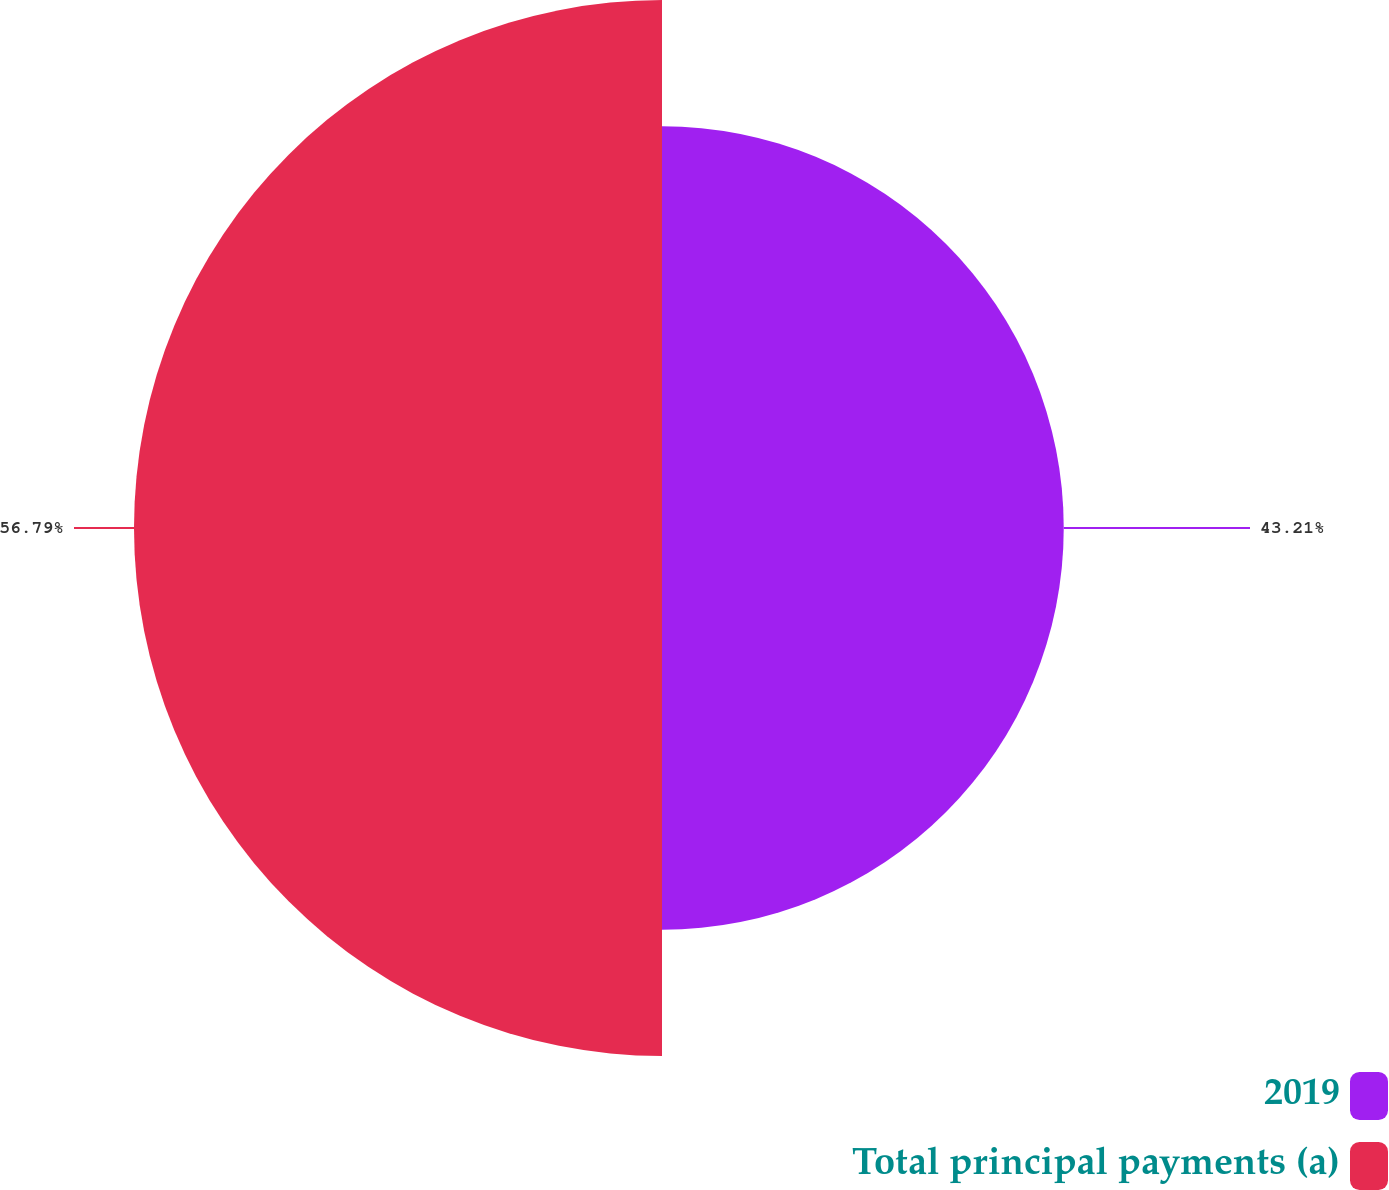Convert chart to OTSL. <chart><loc_0><loc_0><loc_500><loc_500><pie_chart><fcel>2019<fcel>Total principal payments (a)<nl><fcel>43.21%<fcel>56.79%<nl></chart> 